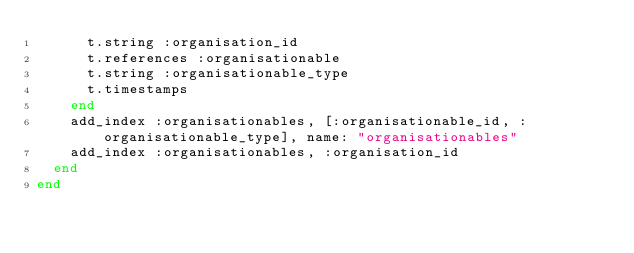Convert code to text. <code><loc_0><loc_0><loc_500><loc_500><_Ruby_>      t.string :organisation_id
      t.references :organisationable
      t.string :organisationable_type
      t.timestamps
    end
    add_index :organisationables, [:organisationable_id, :organisationable_type], name: "organisationables"
    add_index :organisationables, :organisation_id
  end
end
</code> 